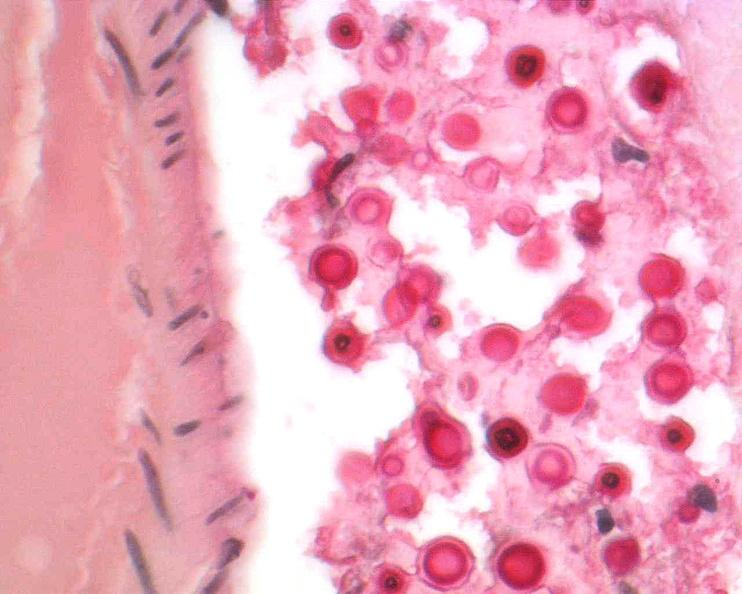do mucicarmine stain?
Answer the question using a single word or phrase. Yes 